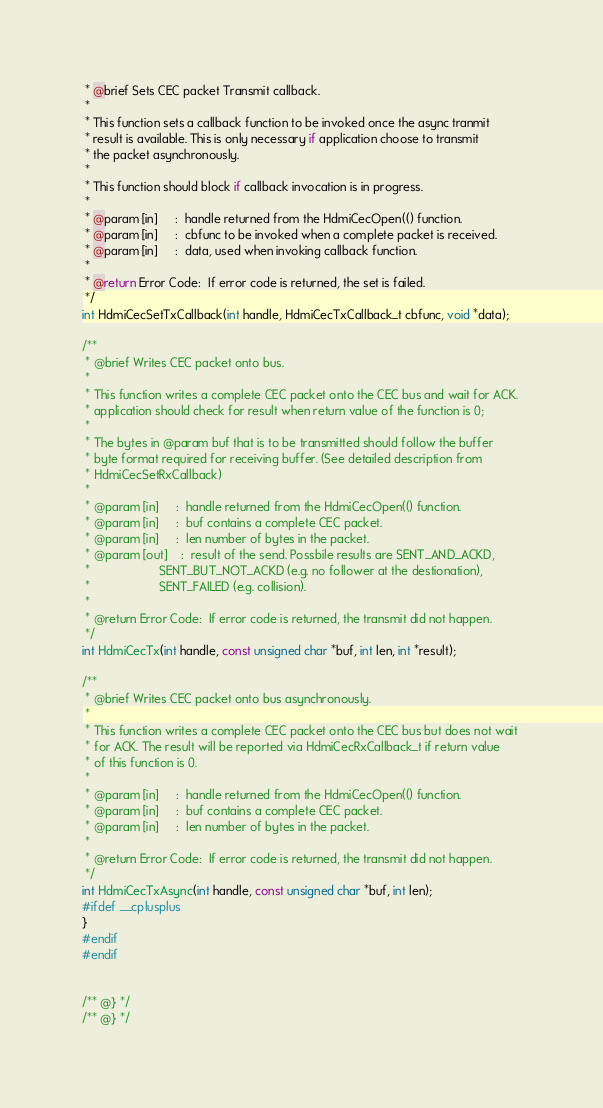Convert code to text. <code><loc_0><loc_0><loc_500><loc_500><_C_> * @brief Sets CEC packet Transmit callback.  
 *
 * This function sets a callback function to be invoked once the async tranmit 
 * result is available. This is only necessary if application choose to transmit
 * the packet asynchronously.
 *
 * This function should block if callback invocation is in progress.
 *
 * @param [in]     :  handle returned from the HdmiCecOpen(() function.
 * @param [in]     :  cbfunc to be invoked when a complete packet is received.
 * @param [in]     :  data, used when invoking callback function. 
 *
 * @return Error Code:  If error code is returned, the set is failed.
 */
int HdmiCecSetTxCallback(int handle, HdmiCecTxCallback_t cbfunc, void *data);

/**
 * @brief Writes CEC packet onto bus.  
 *
 * This function writes a complete CEC packet onto the CEC bus and wait for ACK.
 * application should check for result when return value of the function is 0;
 *
 * The bytes in @param buf that is to be transmitted should follow the buffer
 * byte format required for receiving buffer. (See detailed description from 
 * HdmiCecSetRxCallback)
 *
 * @param [in]     :  handle returned from the HdmiCecOpen(() function.
 * @param [in]     :  buf contains a complete CEC packet.
 * @param [in]     :  len number of bytes in the packet.
 * @param [out]    :  result of the send. Possbile results are SENT_AND_ACKD, 
 *                    SENT_BUT_NOT_ACKD (e.g. no follower at the destionation),
 *                    SENT_FAILED (e.g. collision).
 *
 * @return Error Code:  If error code is returned, the transmit did not happen.
 */
int HdmiCecTx(int handle, const unsigned char *buf, int len, int *result);

/**
 * @brief Writes CEC packet onto bus asynchronously.
 *
 * This function writes a complete CEC packet onto the CEC bus but does not wait 
 * for ACK. The result will be reported via HdmiCecRxCallback_t if return value
 * of this function is 0.
 *
 * @param [in]     :  handle returned from the HdmiCecOpen(() function.
 * @param [in]     :  buf contains a complete CEC packet.
 * @param [in]     :  len number of bytes in the packet.
 *
 * @return Error Code:  If error code is returned, the transmit did not happen.
 */
int HdmiCecTxAsync(int handle, const unsigned char *buf, int len);
#ifdef __cplusplus
}
#endif
#endif


/** @} */
/** @} */
</code> 